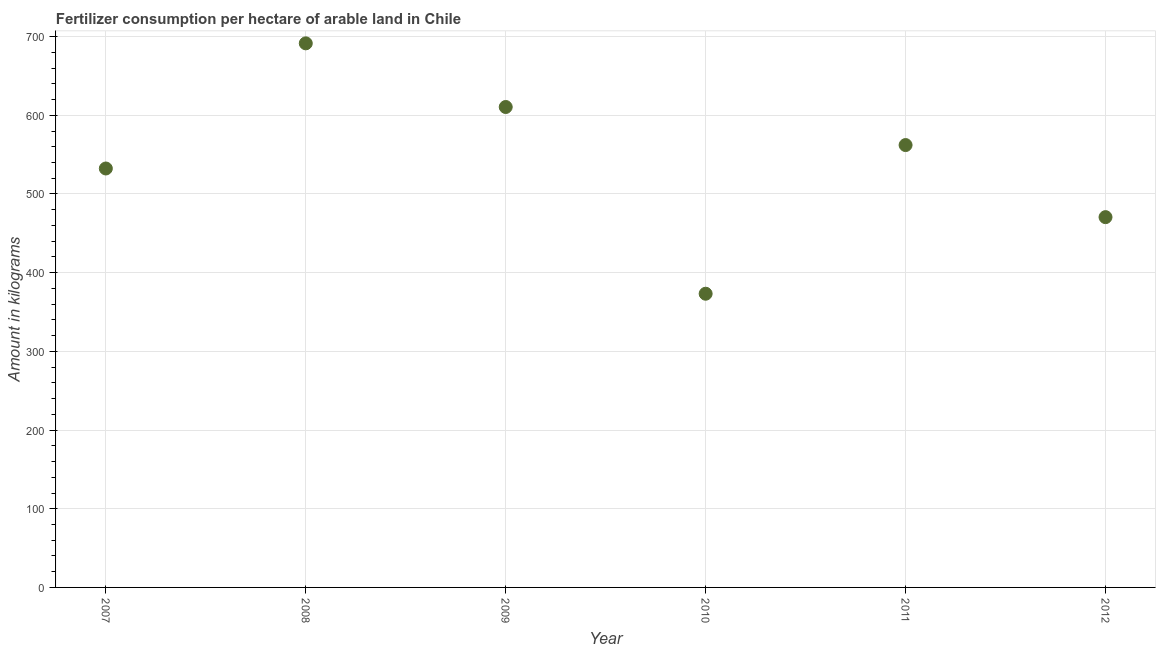What is the amount of fertilizer consumption in 2012?
Ensure brevity in your answer.  470.59. Across all years, what is the maximum amount of fertilizer consumption?
Your answer should be compact. 691.46. Across all years, what is the minimum amount of fertilizer consumption?
Give a very brief answer. 373.25. What is the sum of the amount of fertilizer consumption?
Give a very brief answer. 3240.45. What is the difference between the amount of fertilizer consumption in 2009 and 2012?
Offer a terse response. 139.97. What is the average amount of fertilizer consumption per year?
Provide a short and direct response. 540.07. What is the median amount of fertilizer consumption?
Offer a terse response. 547.3. What is the ratio of the amount of fertilizer consumption in 2007 to that in 2010?
Provide a succinct answer. 1.43. Is the difference between the amount of fertilizer consumption in 2010 and 2011 greater than the difference between any two years?
Offer a very short reply. No. What is the difference between the highest and the second highest amount of fertilizer consumption?
Keep it short and to the point. 80.9. What is the difference between the highest and the lowest amount of fertilizer consumption?
Keep it short and to the point. 318.21. Does the amount of fertilizer consumption monotonically increase over the years?
Provide a short and direct response. No. How many years are there in the graph?
Give a very brief answer. 6. What is the difference between two consecutive major ticks on the Y-axis?
Keep it short and to the point. 100. Are the values on the major ticks of Y-axis written in scientific E-notation?
Keep it short and to the point. No. What is the title of the graph?
Your answer should be very brief. Fertilizer consumption per hectare of arable land in Chile . What is the label or title of the Y-axis?
Your response must be concise. Amount in kilograms. What is the Amount in kilograms in 2007?
Offer a terse response. 532.41. What is the Amount in kilograms in 2008?
Your answer should be very brief. 691.46. What is the Amount in kilograms in 2009?
Provide a succinct answer. 610.55. What is the Amount in kilograms in 2010?
Offer a terse response. 373.25. What is the Amount in kilograms in 2011?
Offer a terse response. 562.19. What is the Amount in kilograms in 2012?
Provide a short and direct response. 470.59. What is the difference between the Amount in kilograms in 2007 and 2008?
Make the answer very short. -159.04. What is the difference between the Amount in kilograms in 2007 and 2009?
Your response must be concise. -78.14. What is the difference between the Amount in kilograms in 2007 and 2010?
Provide a short and direct response. 159.16. What is the difference between the Amount in kilograms in 2007 and 2011?
Offer a very short reply. -29.78. What is the difference between the Amount in kilograms in 2007 and 2012?
Keep it short and to the point. 61.83. What is the difference between the Amount in kilograms in 2008 and 2009?
Make the answer very short. 80.9. What is the difference between the Amount in kilograms in 2008 and 2010?
Keep it short and to the point. 318.21. What is the difference between the Amount in kilograms in 2008 and 2011?
Make the answer very short. 129.27. What is the difference between the Amount in kilograms in 2008 and 2012?
Give a very brief answer. 220.87. What is the difference between the Amount in kilograms in 2009 and 2010?
Keep it short and to the point. 237.3. What is the difference between the Amount in kilograms in 2009 and 2011?
Your answer should be very brief. 48.36. What is the difference between the Amount in kilograms in 2009 and 2012?
Offer a terse response. 139.97. What is the difference between the Amount in kilograms in 2010 and 2011?
Your answer should be very brief. -188.94. What is the difference between the Amount in kilograms in 2010 and 2012?
Keep it short and to the point. -97.34. What is the difference between the Amount in kilograms in 2011 and 2012?
Your response must be concise. 91.6. What is the ratio of the Amount in kilograms in 2007 to that in 2008?
Make the answer very short. 0.77. What is the ratio of the Amount in kilograms in 2007 to that in 2009?
Provide a succinct answer. 0.87. What is the ratio of the Amount in kilograms in 2007 to that in 2010?
Offer a very short reply. 1.43. What is the ratio of the Amount in kilograms in 2007 to that in 2011?
Provide a succinct answer. 0.95. What is the ratio of the Amount in kilograms in 2007 to that in 2012?
Provide a short and direct response. 1.13. What is the ratio of the Amount in kilograms in 2008 to that in 2009?
Ensure brevity in your answer.  1.13. What is the ratio of the Amount in kilograms in 2008 to that in 2010?
Keep it short and to the point. 1.85. What is the ratio of the Amount in kilograms in 2008 to that in 2011?
Offer a very short reply. 1.23. What is the ratio of the Amount in kilograms in 2008 to that in 2012?
Offer a terse response. 1.47. What is the ratio of the Amount in kilograms in 2009 to that in 2010?
Give a very brief answer. 1.64. What is the ratio of the Amount in kilograms in 2009 to that in 2011?
Ensure brevity in your answer.  1.09. What is the ratio of the Amount in kilograms in 2009 to that in 2012?
Keep it short and to the point. 1.3. What is the ratio of the Amount in kilograms in 2010 to that in 2011?
Your response must be concise. 0.66. What is the ratio of the Amount in kilograms in 2010 to that in 2012?
Provide a short and direct response. 0.79. What is the ratio of the Amount in kilograms in 2011 to that in 2012?
Your response must be concise. 1.2. 